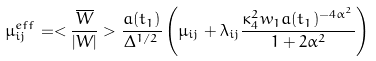Convert formula to latex. <formula><loc_0><loc_0><loc_500><loc_500>\mu _ { i j } ^ { e f f } = < \frac { \overline { W } } { | W | } > \frac { a ( t _ { 1 } ) } { \Delta ^ { 1 / 2 } } \left ( \mu _ { i j } + \lambda _ { i j } \frac { \kappa _ { 4 } ^ { 2 } w _ { 1 } a ( t _ { 1 } ) ^ { - 4 \alpha ^ { 2 } } } { 1 + 2 \alpha ^ { 2 } } \right )</formula> 